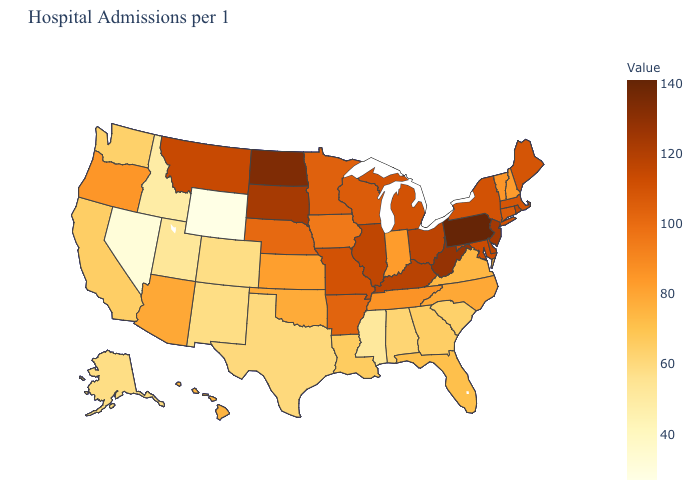Which states have the lowest value in the USA?
Be succinct. Wyoming. Does the map have missing data?
Quick response, please. No. Among the states that border Washington , does Oregon have the lowest value?
Keep it brief. No. Does the map have missing data?
Be succinct. No. Does Georgia have a lower value than Utah?
Be succinct. No. Does Minnesota have the lowest value in the USA?
Answer briefly. No. 